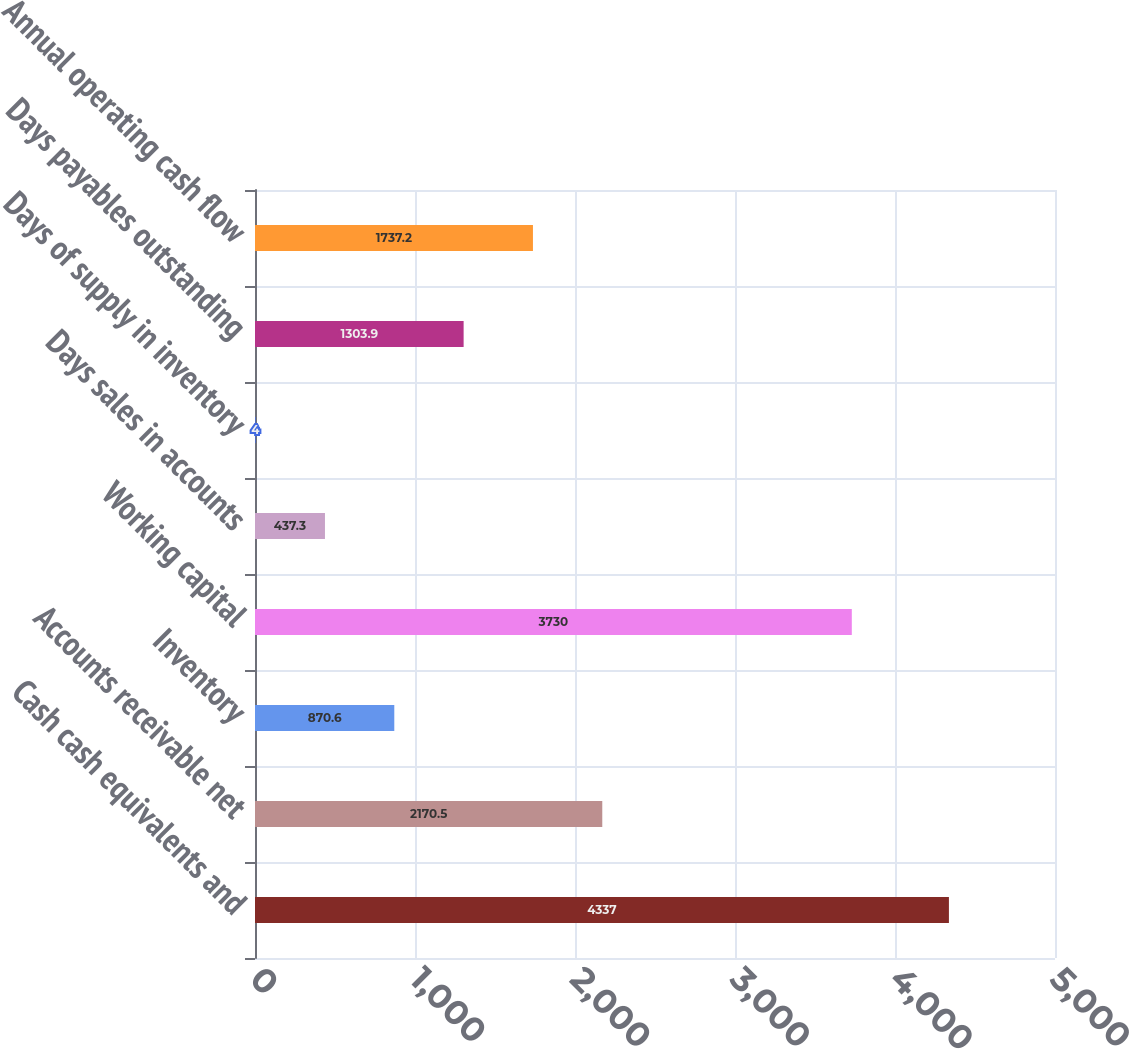<chart> <loc_0><loc_0><loc_500><loc_500><bar_chart><fcel>Cash cash equivalents and<fcel>Accounts receivable net<fcel>Inventory<fcel>Working capital<fcel>Days sales in accounts<fcel>Days of supply in inventory<fcel>Days payables outstanding<fcel>Annual operating cash flow<nl><fcel>4337<fcel>2170.5<fcel>870.6<fcel>3730<fcel>437.3<fcel>4<fcel>1303.9<fcel>1737.2<nl></chart> 